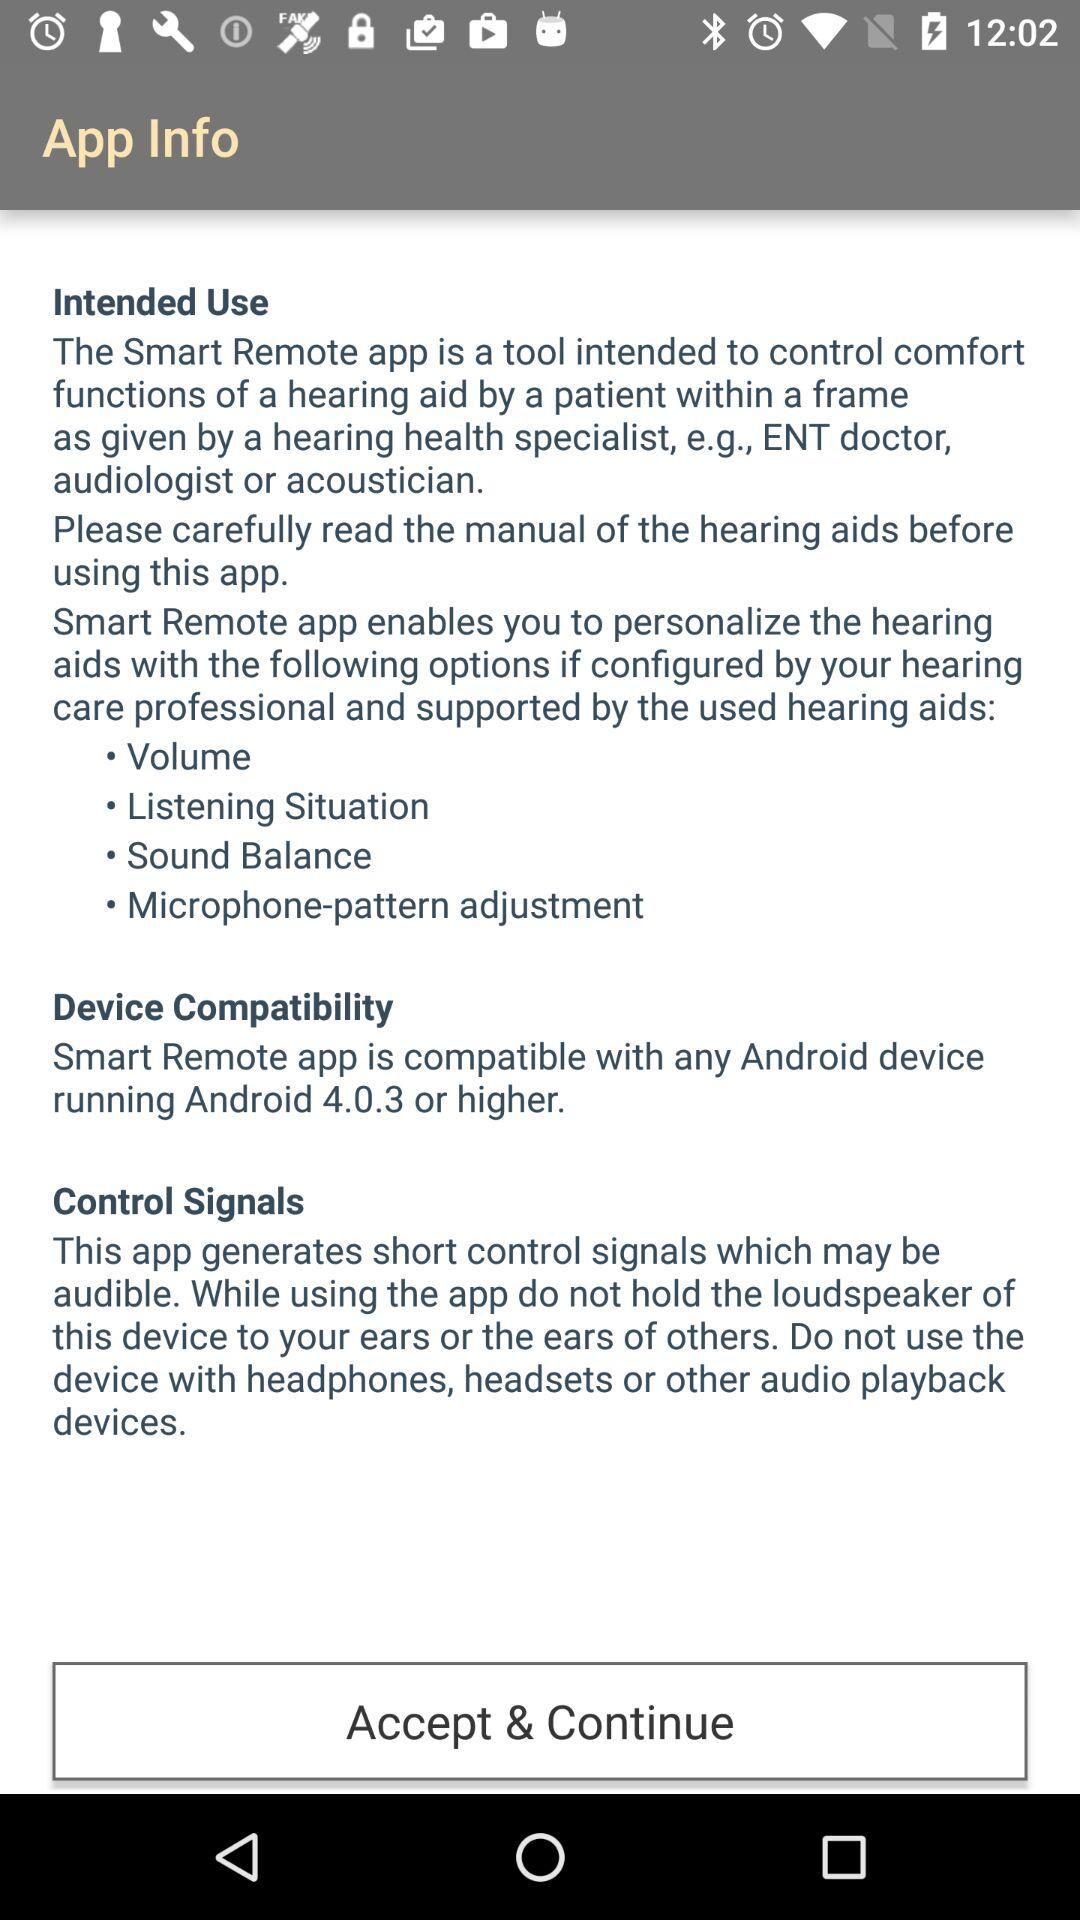What is the Android version? The Android version is 4.0.3 or higher. 